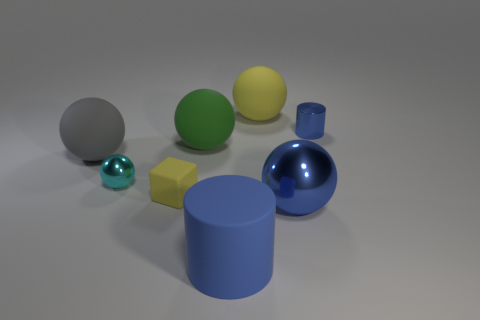Does the rubber cylinder have the same color as the shiny cylinder?
Ensure brevity in your answer.  Yes. Is the blue cylinder that is behind the big blue rubber thing made of the same material as the big ball to the right of the big yellow object?
Give a very brief answer. Yes. How many blue things are in front of the tiny cylinder?
Your response must be concise. 2. How many green objects are rubber balls or big things?
Provide a short and direct response. 1. There is a cyan thing that is the same size as the blue shiny cylinder; what material is it?
Keep it short and to the point. Metal. There is a big thing that is behind the big gray matte sphere and in front of the small blue cylinder; what is its shape?
Keep it short and to the point. Sphere. What is the color of the matte cube that is the same size as the cyan sphere?
Offer a terse response. Yellow. Is the size of the cylinder behind the cube the same as the blue cylinder on the left side of the big blue sphere?
Keep it short and to the point. No. There is a blue cylinder that is in front of the big blue thing that is right of the thing that is behind the small blue cylinder; what is its size?
Provide a short and direct response. Large. The blue metal thing that is in front of the cylinder that is behind the big blue metal ball is what shape?
Ensure brevity in your answer.  Sphere. 